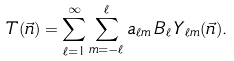Convert formula to latex. <formula><loc_0><loc_0><loc_500><loc_500>T ( \vec { n } ) = \sum _ { \ell = 1 } ^ { \infty } \sum _ { m = - \ell } ^ { \ell } a _ { \ell m } \, B _ { \ell } \, Y _ { \ell m } ( \vec { n } ) .</formula> 